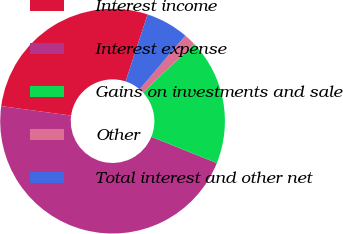Convert chart to OTSL. <chart><loc_0><loc_0><loc_500><loc_500><pie_chart><fcel>Interest income<fcel>Interest expense<fcel>Gains on investments and sale<fcel>Other<fcel>Total interest and other net<nl><fcel>27.91%<fcel>46.05%<fcel>18.14%<fcel>1.73%<fcel>6.17%<nl></chart> 